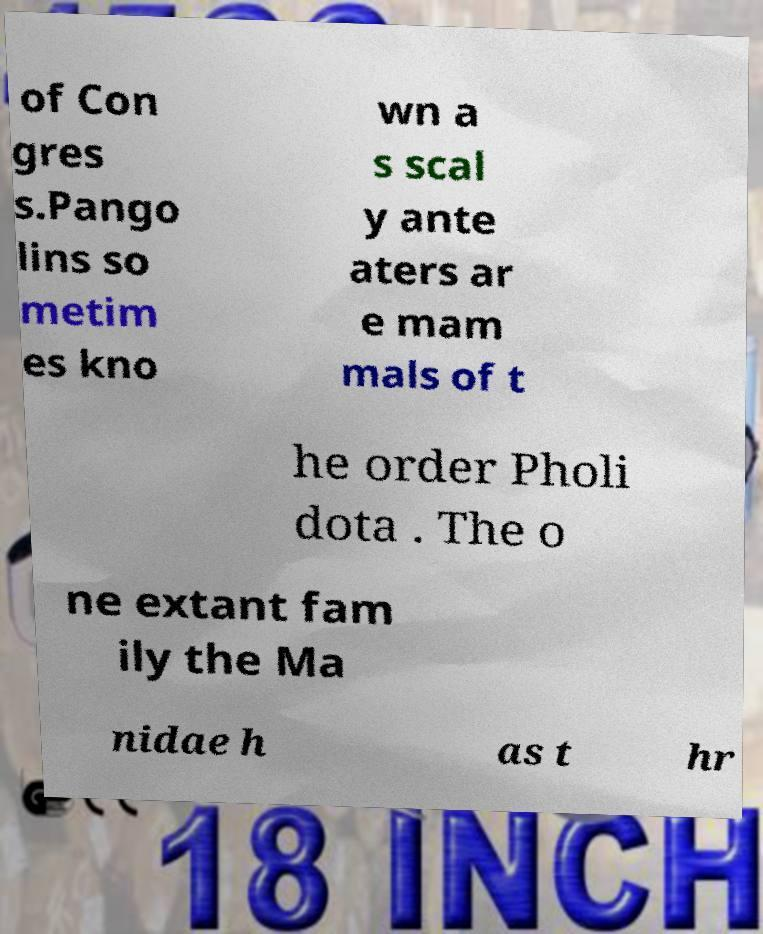There's text embedded in this image that I need extracted. Can you transcribe it verbatim? of Con gres s.Pango lins so metim es kno wn a s scal y ante aters ar e mam mals of t he order Pholi dota . The o ne extant fam ily the Ma nidae h as t hr 